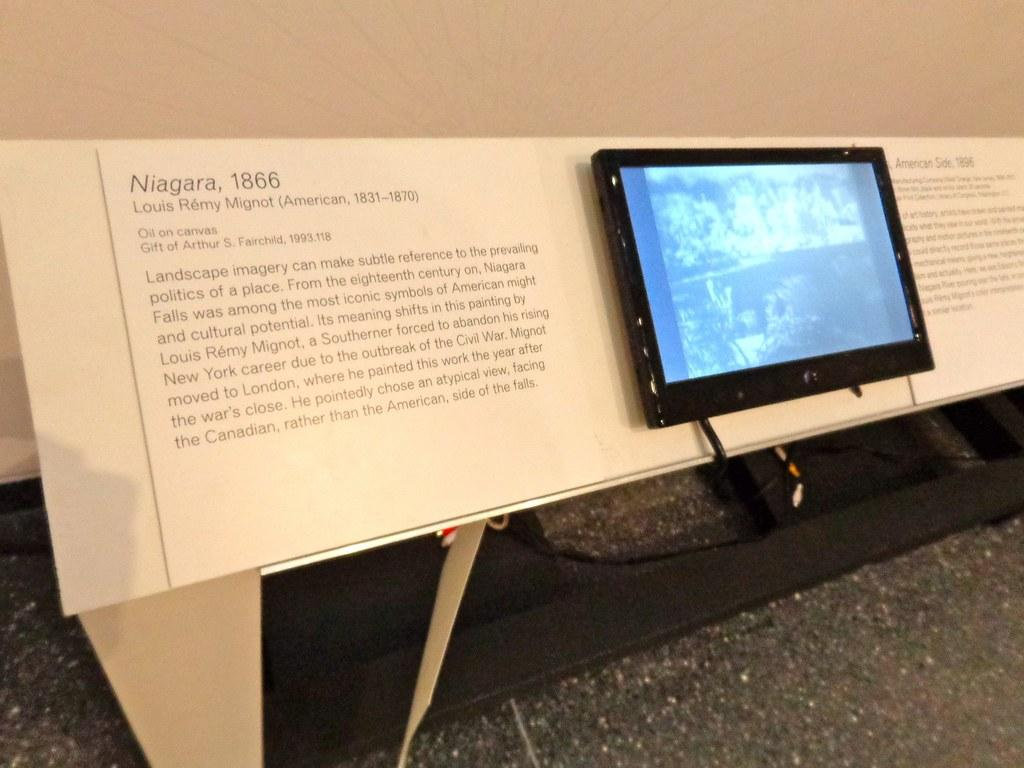What is the main object in the image? There is a screen in the image. What other object can be seen in the image? There is a board in the image. Where is the text located in the image? The text is written on the left side of the image. What can be seen under the screen and board? The floor is visible in the image. What is visible behind the screen and board? There is a wall in the background of the image. What type of toys can be seen on the range in the image? There are no toys or range present in the image. 